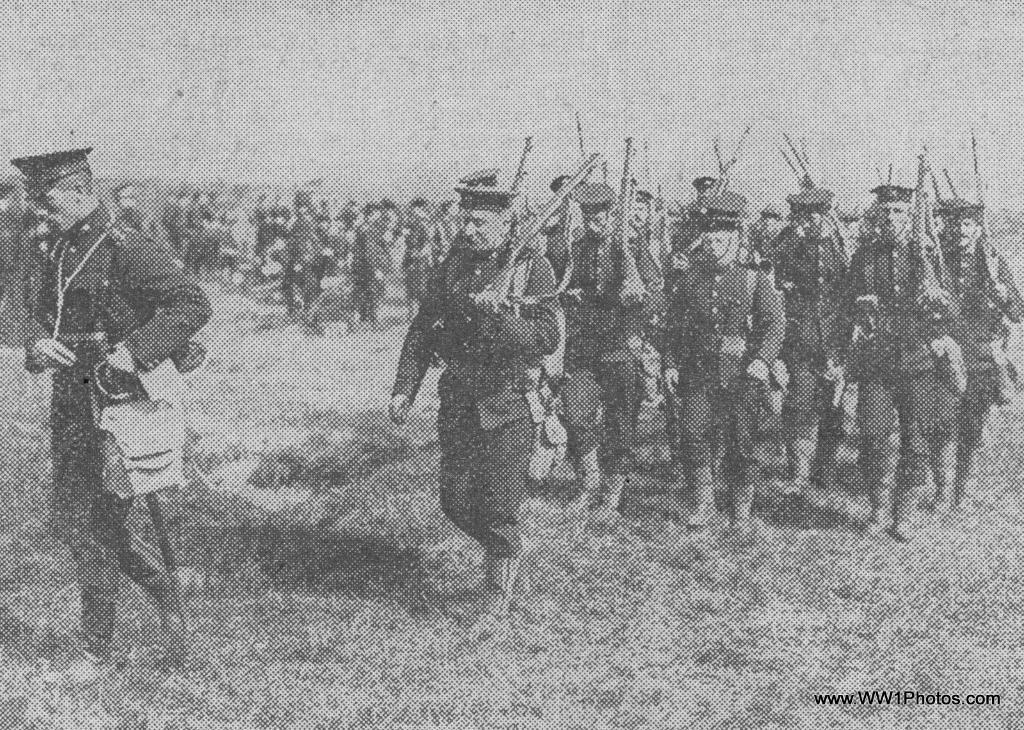In one or two sentences, can you explain what this image depicts? In this picture I can see some people are holding guns and walking on the grass. 